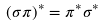Convert formula to latex. <formula><loc_0><loc_0><loc_500><loc_500>( \sigma \pi ) ^ { * } = \pi ^ { * } \sigma ^ { * }</formula> 